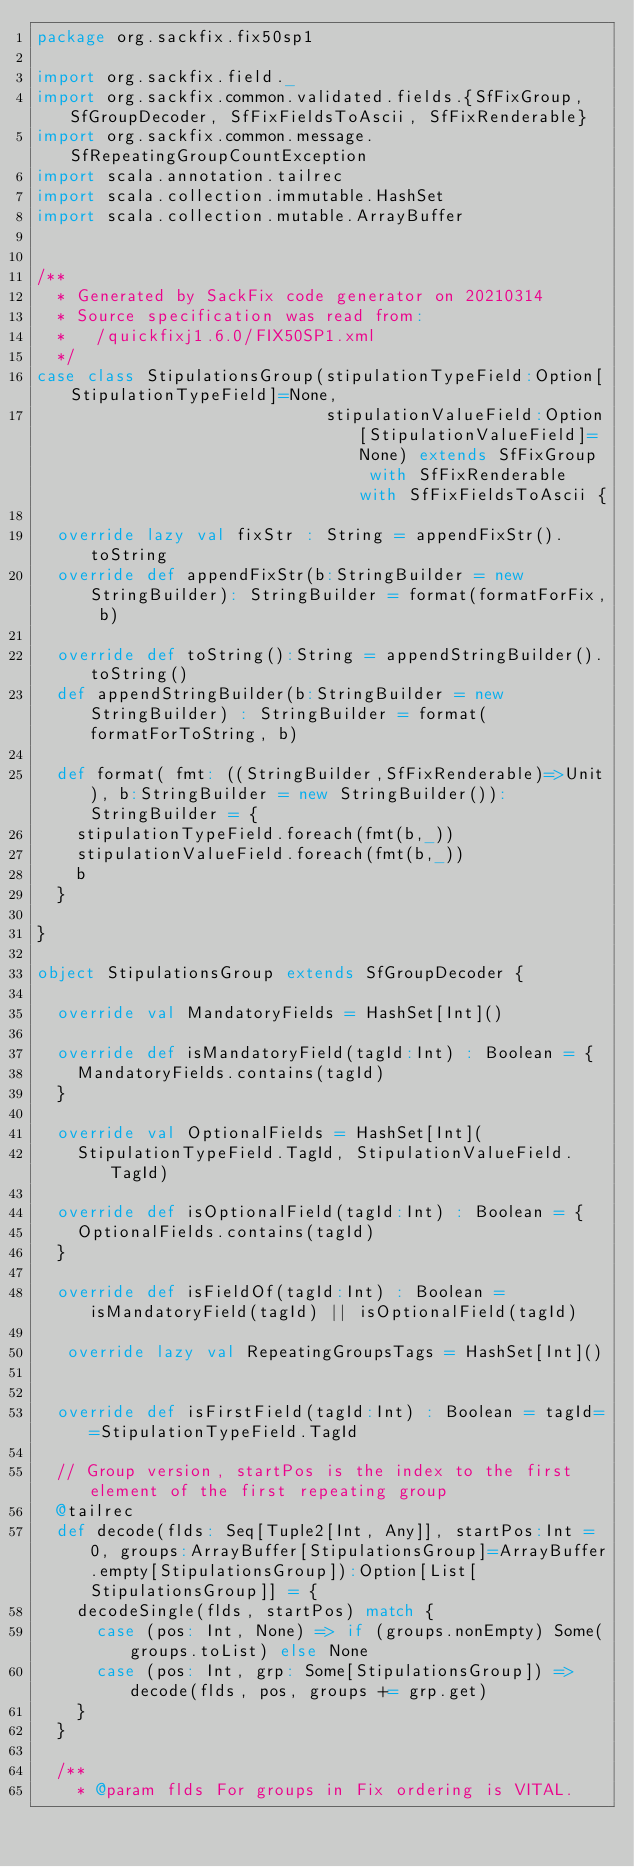Convert code to text. <code><loc_0><loc_0><loc_500><loc_500><_Scala_>package org.sackfix.fix50sp1

import org.sackfix.field._
import org.sackfix.common.validated.fields.{SfFixGroup, SfGroupDecoder, SfFixFieldsToAscii, SfFixRenderable}
import org.sackfix.common.message.SfRepeatingGroupCountException
import scala.annotation.tailrec
import scala.collection.immutable.HashSet
import scala.collection.mutable.ArrayBuffer


/**
  * Generated by SackFix code generator on 20210314
  * Source specification was read from:
  *   /quickfixj1.6.0/FIX50SP1.xml
  */
case class StipulationsGroup(stipulationTypeField:Option[StipulationTypeField]=None,
                             stipulationValueField:Option[StipulationValueField]=None) extends SfFixGroup  with SfFixRenderable with SfFixFieldsToAscii {

  override lazy val fixStr : String = appendFixStr().toString
  override def appendFixStr(b:StringBuilder = new StringBuilder): StringBuilder = format(formatForFix, b)

  override def toString():String = appendStringBuilder().toString()
  def appendStringBuilder(b:StringBuilder = new StringBuilder) : StringBuilder = format(formatForToString, b)

  def format( fmt: ((StringBuilder,SfFixRenderable)=>Unit), b:StringBuilder = new StringBuilder()): StringBuilder = {
    stipulationTypeField.foreach(fmt(b,_))
    stipulationValueField.foreach(fmt(b,_))
    b
  }

}
     
object StipulationsGroup extends SfGroupDecoder {

  override val MandatoryFields = HashSet[Int]()

  override def isMandatoryField(tagId:Int) : Boolean = {
    MandatoryFields.contains(tagId) 
  }

  override val OptionalFields = HashSet[Int](
    StipulationTypeField.TagId, StipulationValueField.TagId)

  override def isOptionalField(tagId:Int) : Boolean = {
    OptionalFields.contains(tagId) 
  }

  override def isFieldOf(tagId:Int) : Boolean = isMandatoryField(tagId) || isOptionalField(tagId) 

   override lazy val RepeatingGroupsTags = HashSet[Int]()
  
      
  override def isFirstField(tagId:Int) : Boolean = tagId==StipulationTypeField.TagId 

  // Group version, startPos is the index to the first element of the first repeating group
  @tailrec
  def decode(flds: Seq[Tuple2[Int, Any]], startPos:Int = 0, groups:ArrayBuffer[StipulationsGroup]=ArrayBuffer.empty[StipulationsGroup]):Option[List[StipulationsGroup]] = {
    decodeSingle(flds, startPos) match {
      case (pos: Int, None) => if (groups.nonEmpty) Some(groups.toList) else None
      case (pos: Int, grp: Some[StipulationsGroup]) => decode(flds, pos, groups += grp.get)
    }
  }

  /**
    * @param flds For groups in Fix ordering is VITAL.</code> 